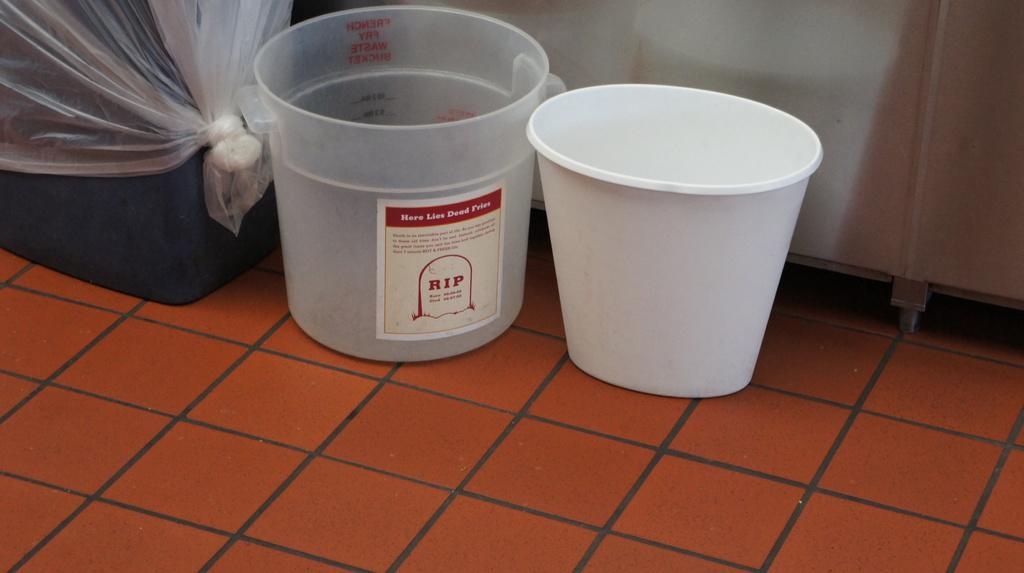<image>
Present a compact description of the photo's key features. A bucket for old fries, labeled Here Lies Dead Fries, sits on the floor. 